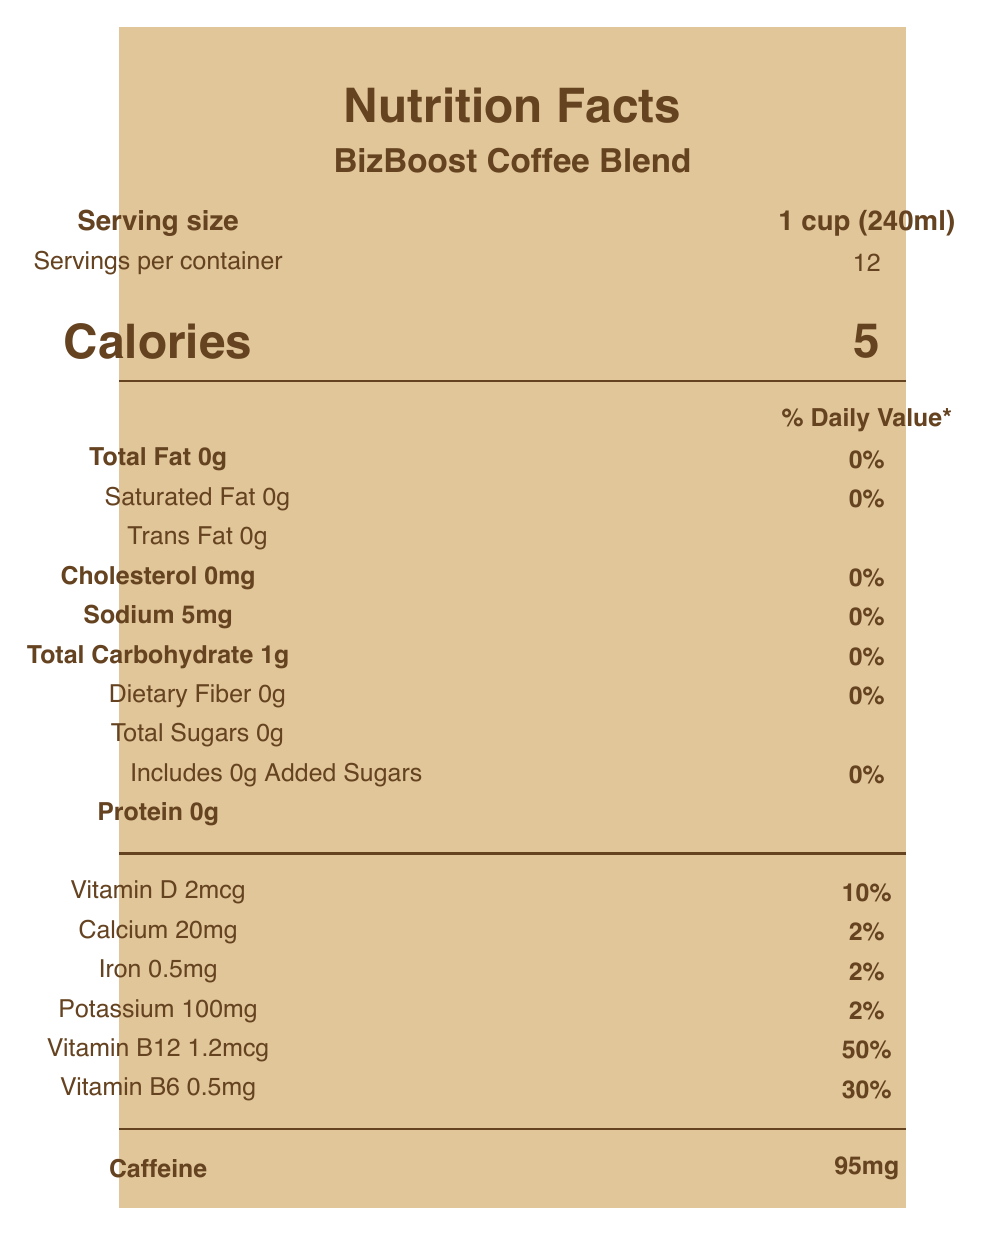what is the serving size of BizBoost Coffee Blend? The serving size is mentioned right below the product name as "1 cup (240ml)".
Answer: 1 cup (240ml) how many calories are there per serving? The calorie content per serving is prominently displayed as "Calories 5".
Answer: 5 which vitamin has the highest daily value percentage in one serving? The percentage of Daily Value for Vitamin B12 is the highest at 50%.
Answer: Vitamin B12 how much caffeine is there in one serving? The caffeine content is listed at the bottom of the document as "Caffeine 95mg".
Answer: 95mg what is the amount of total carbohydrates per serving? The document states "Total Carbohydrate 1g" under the macronutrients section.
Answer: 1g which vitamins are included in the vitamin and mineral blend? A. Riboflavin and Sodium B. Vitamin D and Calcium C. Vitamin E and Potassium D. Thiamin and Copper The ingredients list contains "Vitamin and mineral blend (vitamin D, calcium, iron, potassium, vitamin B12, vitamin B6, niacin, pantothenic acid, riboflavin, thiamin)".
Answer: B what percentage of the daily value of Vitamin B6 is in one serving? A. 10% B. 30% C. 50% D. 100% The document shows "Vitamin B6 0.5mg (30% DV)".
Answer: B is BizBoost Coffee Blend made with Arabica coffee? The ingredient list includes "Arabica coffee".
Answer: Yes does this product contain any protein? The document lists "Protein 0g" which indicates there is no protein in the product.
Answer: No summarize the main information presented in the nutrition label. The document details the nutritional content per serving and highlights its enrichment with vitamins and claims about its benefits for business professionals.
Answer: BizBoost Coffee Blend contains 5 calories per serving, is low in fat, cholesterol, and sodium, and has no sugars or protein. It's enriched with several vitamins and minerals, particularly B-vitamins, designed to support cognitive function and energy levels. The product highlights its caffeine content and is sourced from Rainforest Alliance Certified farms. how is this coffee blend described in terms of performance? The visual document does not include detailed descriptions or testimonials describing the specific performance impact of the coffee blend.
Answer: Not enough information 